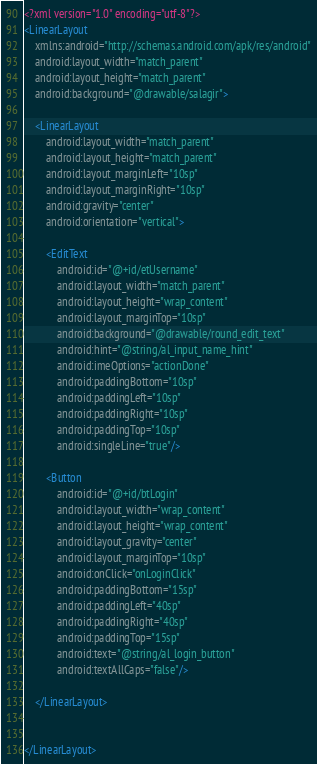Convert code to text. <code><loc_0><loc_0><loc_500><loc_500><_XML_><?xml version="1.0" encoding="utf-8"?>
<LinearLayout
    xmlns:android="http://schemas.android.com/apk/res/android"
    android:layout_width="match_parent"
    android:layout_height="match_parent"
    android:background="@drawable/salagir">

    <LinearLayout
        android:layout_width="match_parent"
        android:layout_height="match_parent"
        android:layout_marginLeft="10sp"
        android:layout_marginRight="10sp"
        android:gravity="center"
        android:orientation="vertical">

        <EditText
            android:id="@+id/etUsername"
            android:layout_width="match_parent"
            android:layout_height="wrap_content"
            android:layout_marginTop="10sp"
            android:background="@drawable/round_edit_text"
            android:hint="@string/al_input_name_hint"
            android:imeOptions="actionDone"
            android:paddingBottom="10sp"
            android:paddingLeft="10sp"
            android:paddingRight="10sp"
            android:paddingTop="10sp"
            android:singleLine="true"/>

        <Button
            android:id="@+id/btLogin"
            android:layout_width="wrap_content"
            android:layout_height="wrap_content"
            android:layout_gravity="center"
            android:layout_marginTop="10sp"
            android:onClick="onLoginClick"
            android:paddingBottom="15sp"
            android:paddingLeft="40sp"
            android:paddingRight="40sp"
            android:paddingTop="15sp"
            android:text="@string/al_login_button"
            android:textAllCaps="false"/>

    </LinearLayout>


</LinearLayout>
</code> 